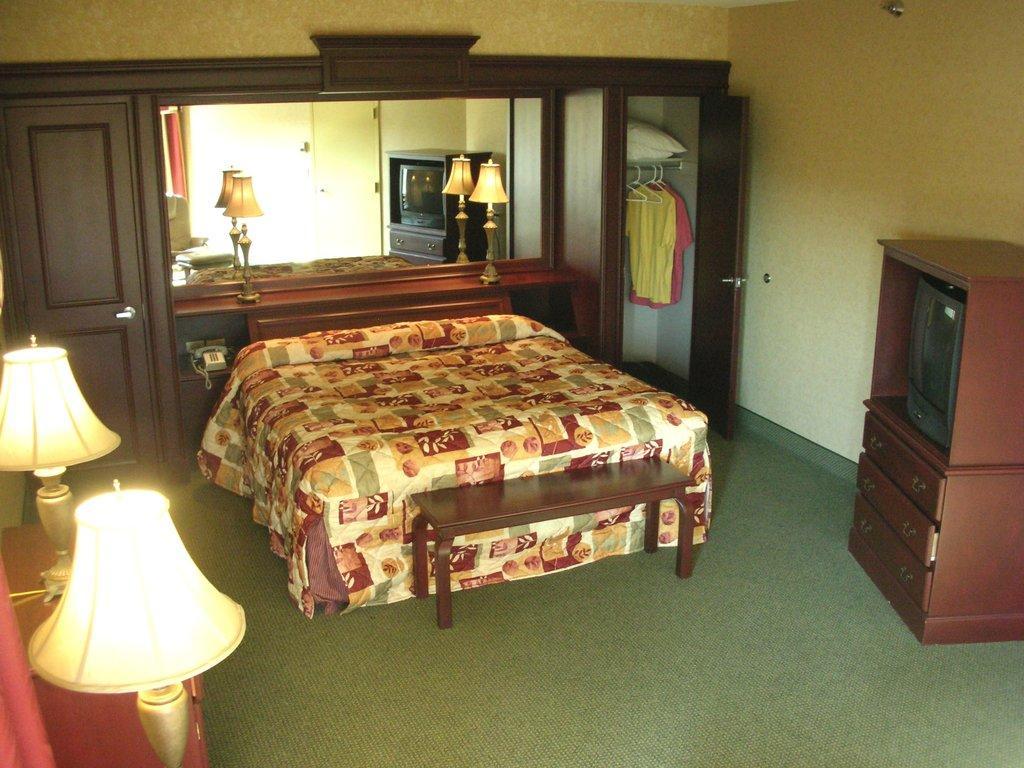How would you summarize this image in a sentence or two? The picture is clicked inside the house and a bed ,television , cupboard, bed lamps and wooden door is in it. 